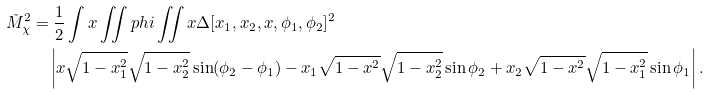<formula> <loc_0><loc_0><loc_500><loc_500>\check { M } _ { \chi } ^ { 2 } & = \frac { 1 } { 2 } \int x \iint p h i \iint x \Delta [ x _ { 1 } , x _ { 2 } , x , \phi _ { 1 } , \phi _ { 2 } ] ^ { 2 } \\ & \quad \left | x \sqrt { 1 - x _ { 1 } ^ { 2 } } \sqrt { 1 - x _ { 2 } ^ { 2 } } \sin ( \phi _ { 2 } - \phi _ { 1 } ) - x _ { 1 } \sqrt { 1 - x ^ { 2 } } \sqrt { 1 - x _ { 2 } ^ { 2 } } \sin \phi _ { 2 } + x _ { 2 } \sqrt { 1 - x ^ { 2 } } \sqrt { 1 - x _ { 1 } ^ { 2 } } \sin \phi _ { 1 } \right | .</formula> 